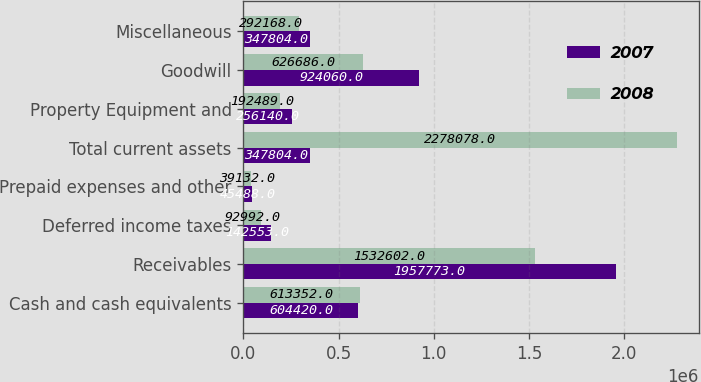Convert chart to OTSL. <chart><loc_0><loc_0><loc_500><loc_500><stacked_bar_chart><ecel><fcel>Cash and cash equivalents<fcel>Receivables<fcel>Deferred income taxes<fcel>Prepaid expenses and other<fcel>Total current assets<fcel>Property Equipment and<fcel>Goodwill<fcel>Miscellaneous<nl><fcel>2007<fcel>604420<fcel>1.95777e+06<fcel>142553<fcel>45488<fcel>347804<fcel>256140<fcel>924060<fcel>347804<nl><fcel>2008<fcel>613352<fcel>1.5326e+06<fcel>92992<fcel>39132<fcel>2.27808e+06<fcel>192489<fcel>626686<fcel>292168<nl></chart> 